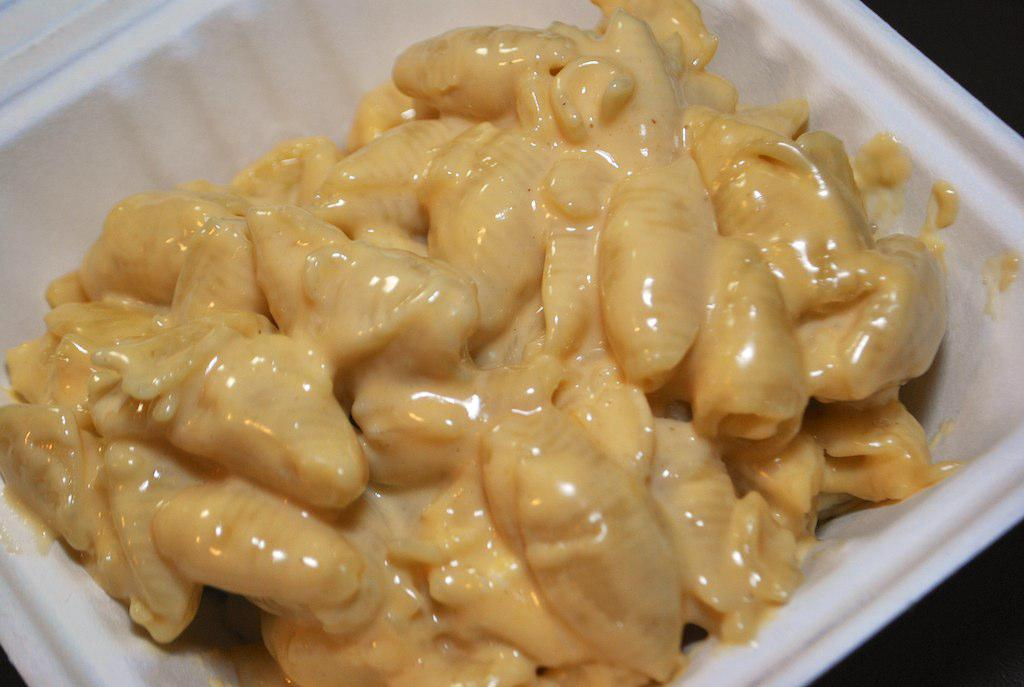What is placed in a bowl in the image? There is an eatable thing placed in a bowl in the image. What type of copper material can be seen in the image? There is no copper material present in the image. Is there a bridge visible in the image? No, there is no bridge visible in the image. 